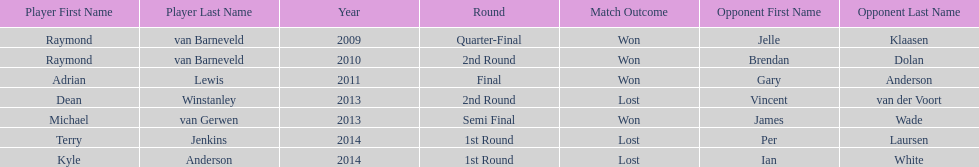Other than kyle anderson, who else lost in 2014? Terry Jenkins. 